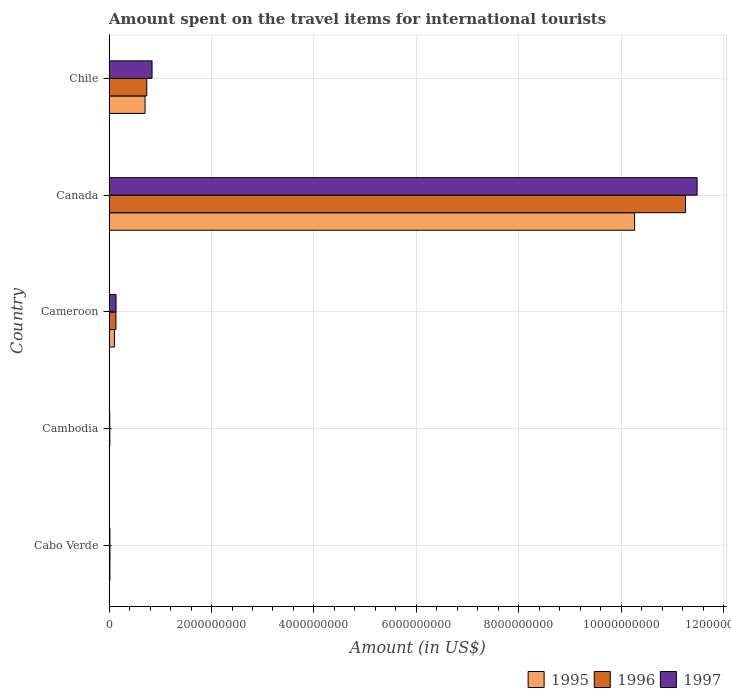How many different coloured bars are there?
Keep it short and to the point. 3. How many groups of bars are there?
Offer a terse response. 5. Are the number of bars on each tick of the Y-axis equal?
Offer a terse response. Yes. How many bars are there on the 5th tick from the bottom?
Your answer should be very brief. 3. What is the label of the 3rd group of bars from the top?
Your response must be concise. Cameroon. In how many cases, is the number of bars for a given country not equal to the number of legend labels?
Provide a short and direct response. 0. What is the amount spent on the travel items for international tourists in 1996 in Canada?
Provide a short and direct response. 1.13e+1. Across all countries, what is the maximum amount spent on the travel items for international tourists in 1995?
Your answer should be very brief. 1.03e+1. Across all countries, what is the minimum amount spent on the travel items for international tourists in 1997?
Give a very brief answer. 1.30e+07. In which country was the amount spent on the travel items for international tourists in 1997 minimum?
Your response must be concise. Cambodia. What is the total amount spent on the travel items for international tourists in 1997 in the graph?
Your answer should be very brief. 1.25e+1. What is the difference between the amount spent on the travel items for international tourists in 1995 in Cambodia and that in Canada?
Provide a succinct answer. -1.03e+1. What is the difference between the amount spent on the travel items for international tourists in 1996 in Chile and the amount spent on the travel items for international tourists in 1997 in Cambodia?
Give a very brief answer. 7.23e+08. What is the average amount spent on the travel items for international tourists in 1996 per country?
Offer a very short reply. 2.43e+09. What is the difference between the amount spent on the travel items for international tourists in 1995 and amount spent on the travel items for international tourists in 1997 in Chile?
Your response must be concise. -1.36e+08. What is the ratio of the amount spent on the travel items for international tourists in 1997 in Cabo Verde to that in Chile?
Provide a succinct answer. 0.02. What is the difference between the highest and the second highest amount spent on the travel items for international tourists in 1996?
Offer a very short reply. 1.05e+1. What is the difference between the highest and the lowest amount spent on the travel items for international tourists in 1996?
Your answer should be compact. 1.12e+1. In how many countries, is the amount spent on the travel items for international tourists in 1995 greater than the average amount spent on the travel items for international tourists in 1995 taken over all countries?
Give a very brief answer. 1. Is it the case that in every country, the sum of the amount spent on the travel items for international tourists in 1997 and amount spent on the travel items for international tourists in 1995 is greater than the amount spent on the travel items for international tourists in 1996?
Ensure brevity in your answer.  Yes. How many bars are there?
Ensure brevity in your answer.  15. How many countries are there in the graph?
Make the answer very short. 5. Are the values on the major ticks of X-axis written in scientific E-notation?
Provide a succinct answer. No. How are the legend labels stacked?
Provide a succinct answer. Horizontal. What is the title of the graph?
Offer a terse response. Amount spent on the travel items for international tourists. What is the label or title of the X-axis?
Your answer should be compact. Amount (in US$). What is the Amount (in US$) of 1995 in Cabo Verde?
Provide a short and direct response. 1.60e+07. What is the Amount (in US$) in 1996 in Cabo Verde?
Your answer should be very brief. 1.80e+07. What is the Amount (in US$) in 1997 in Cabo Verde?
Make the answer very short. 1.70e+07. What is the Amount (in US$) of 1995 in Cambodia?
Give a very brief answer. 8.00e+06. What is the Amount (in US$) of 1996 in Cambodia?
Your answer should be compact. 1.50e+07. What is the Amount (in US$) in 1997 in Cambodia?
Your answer should be compact. 1.30e+07. What is the Amount (in US$) of 1995 in Cameroon?
Your response must be concise. 1.05e+08. What is the Amount (in US$) of 1996 in Cameroon?
Keep it short and to the point. 1.34e+08. What is the Amount (in US$) of 1997 in Cameroon?
Your response must be concise. 1.36e+08. What is the Amount (in US$) of 1995 in Canada?
Your answer should be compact. 1.03e+1. What is the Amount (in US$) of 1996 in Canada?
Your answer should be very brief. 1.13e+1. What is the Amount (in US$) in 1997 in Canada?
Offer a very short reply. 1.15e+1. What is the Amount (in US$) of 1995 in Chile?
Provide a succinct answer. 7.03e+08. What is the Amount (in US$) of 1996 in Chile?
Your answer should be compact. 7.36e+08. What is the Amount (in US$) in 1997 in Chile?
Give a very brief answer. 8.39e+08. Across all countries, what is the maximum Amount (in US$) of 1995?
Provide a succinct answer. 1.03e+1. Across all countries, what is the maximum Amount (in US$) of 1996?
Offer a terse response. 1.13e+1. Across all countries, what is the maximum Amount (in US$) of 1997?
Ensure brevity in your answer.  1.15e+1. Across all countries, what is the minimum Amount (in US$) of 1995?
Make the answer very short. 8.00e+06. Across all countries, what is the minimum Amount (in US$) of 1996?
Offer a terse response. 1.50e+07. Across all countries, what is the minimum Amount (in US$) in 1997?
Make the answer very short. 1.30e+07. What is the total Amount (in US$) of 1995 in the graph?
Offer a terse response. 1.11e+1. What is the total Amount (in US$) of 1996 in the graph?
Give a very brief answer. 1.22e+1. What is the total Amount (in US$) of 1997 in the graph?
Offer a terse response. 1.25e+1. What is the difference between the Amount (in US$) in 1995 in Cabo Verde and that in Cameroon?
Your answer should be compact. -8.90e+07. What is the difference between the Amount (in US$) in 1996 in Cabo Verde and that in Cameroon?
Keep it short and to the point. -1.16e+08. What is the difference between the Amount (in US$) in 1997 in Cabo Verde and that in Cameroon?
Your answer should be very brief. -1.19e+08. What is the difference between the Amount (in US$) in 1995 in Cabo Verde and that in Canada?
Provide a succinct answer. -1.02e+1. What is the difference between the Amount (in US$) of 1996 in Cabo Verde and that in Canada?
Ensure brevity in your answer.  -1.12e+1. What is the difference between the Amount (in US$) of 1997 in Cabo Verde and that in Canada?
Offer a very short reply. -1.15e+1. What is the difference between the Amount (in US$) of 1995 in Cabo Verde and that in Chile?
Make the answer very short. -6.87e+08. What is the difference between the Amount (in US$) of 1996 in Cabo Verde and that in Chile?
Offer a terse response. -7.18e+08. What is the difference between the Amount (in US$) of 1997 in Cabo Verde and that in Chile?
Provide a short and direct response. -8.22e+08. What is the difference between the Amount (in US$) of 1995 in Cambodia and that in Cameroon?
Keep it short and to the point. -9.70e+07. What is the difference between the Amount (in US$) in 1996 in Cambodia and that in Cameroon?
Your answer should be compact. -1.19e+08. What is the difference between the Amount (in US$) of 1997 in Cambodia and that in Cameroon?
Offer a terse response. -1.23e+08. What is the difference between the Amount (in US$) in 1995 in Cambodia and that in Canada?
Your response must be concise. -1.03e+1. What is the difference between the Amount (in US$) in 1996 in Cambodia and that in Canada?
Offer a very short reply. -1.12e+1. What is the difference between the Amount (in US$) of 1997 in Cambodia and that in Canada?
Offer a terse response. -1.15e+1. What is the difference between the Amount (in US$) of 1995 in Cambodia and that in Chile?
Your answer should be compact. -6.95e+08. What is the difference between the Amount (in US$) in 1996 in Cambodia and that in Chile?
Your answer should be very brief. -7.21e+08. What is the difference between the Amount (in US$) of 1997 in Cambodia and that in Chile?
Keep it short and to the point. -8.26e+08. What is the difference between the Amount (in US$) of 1995 in Cameroon and that in Canada?
Give a very brief answer. -1.02e+1. What is the difference between the Amount (in US$) of 1996 in Cameroon and that in Canada?
Give a very brief answer. -1.11e+1. What is the difference between the Amount (in US$) of 1997 in Cameroon and that in Canada?
Offer a terse response. -1.13e+1. What is the difference between the Amount (in US$) in 1995 in Cameroon and that in Chile?
Give a very brief answer. -5.98e+08. What is the difference between the Amount (in US$) of 1996 in Cameroon and that in Chile?
Keep it short and to the point. -6.02e+08. What is the difference between the Amount (in US$) of 1997 in Cameroon and that in Chile?
Provide a succinct answer. -7.03e+08. What is the difference between the Amount (in US$) in 1995 in Canada and that in Chile?
Your answer should be compact. 9.56e+09. What is the difference between the Amount (in US$) in 1996 in Canada and that in Chile?
Give a very brief answer. 1.05e+1. What is the difference between the Amount (in US$) in 1997 in Canada and that in Chile?
Your response must be concise. 1.06e+1. What is the difference between the Amount (in US$) in 1996 in Cabo Verde and the Amount (in US$) in 1997 in Cambodia?
Provide a succinct answer. 5.00e+06. What is the difference between the Amount (in US$) in 1995 in Cabo Verde and the Amount (in US$) in 1996 in Cameroon?
Your answer should be compact. -1.18e+08. What is the difference between the Amount (in US$) of 1995 in Cabo Verde and the Amount (in US$) of 1997 in Cameroon?
Your answer should be very brief. -1.20e+08. What is the difference between the Amount (in US$) in 1996 in Cabo Verde and the Amount (in US$) in 1997 in Cameroon?
Your answer should be very brief. -1.18e+08. What is the difference between the Amount (in US$) of 1995 in Cabo Verde and the Amount (in US$) of 1996 in Canada?
Your answer should be very brief. -1.12e+1. What is the difference between the Amount (in US$) in 1995 in Cabo Verde and the Amount (in US$) in 1997 in Canada?
Ensure brevity in your answer.  -1.15e+1. What is the difference between the Amount (in US$) in 1996 in Cabo Verde and the Amount (in US$) in 1997 in Canada?
Give a very brief answer. -1.15e+1. What is the difference between the Amount (in US$) of 1995 in Cabo Verde and the Amount (in US$) of 1996 in Chile?
Your answer should be very brief. -7.20e+08. What is the difference between the Amount (in US$) in 1995 in Cabo Verde and the Amount (in US$) in 1997 in Chile?
Give a very brief answer. -8.23e+08. What is the difference between the Amount (in US$) in 1996 in Cabo Verde and the Amount (in US$) in 1997 in Chile?
Make the answer very short. -8.21e+08. What is the difference between the Amount (in US$) in 1995 in Cambodia and the Amount (in US$) in 1996 in Cameroon?
Provide a succinct answer. -1.26e+08. What is the difference between the Amount (in US$) of 1995 in Cambodia and the Amount (in US$) of 1997 in Cameroon?
Offer a terse response. -1.28e+08. What is the difference between the Amount (in US$) of 1996 in Cambodia and the Amount (in US$) of 1997 in Cameroon?
Your response must be concise. -1.21e+08. What is the difference between the Amount (in US$) of 1995 in Cambodia and the Amount (in US$) of 1996 in Canada?
Your answer should be very brief. -1.12e+1. What is the difference between the Amount (in US$) of 1995 in Cambodia and the Amount (in US$) of 1997 in Canada?
Provide a succinct answer. -1.15e+1. What is the difference between the Amount (in US$) in 1996 in Cambodia and the Amount (in US$) in 1997 in Canada?
Your answer should be very brief. -1.15e+1. What is the difference between the Amount (in US$) of 1995 in Cambodia and the Amount (in US$) of 1996 in Chile?
Your answer should be very brief. -7.28e+08. What is the difference between the Amount (in US$) of 1995 in Cambodia and the Amount (in US$) of 1997 in Chile?
Your response must be concise. -8.31e+08. What is the difference between the Amount (in US$) in 1996 in Cambodia and the Amount (in US$) in 1997 in Chile?
Ensure brevity in your answer.  -8.24e+08. What is the difference between the Amount (in US$) in 1995 in Cameroon and the Amount (in US$) in 1996 in Canada?
Provide a short and direct response. -1.11e+1. What is the difference between the Amount (in US$) of 1995 in Cameroon and the Amount (in US$) of 1997 in Canada?
Your answer should be very brief. -1.14e+1. What is the difference between the Amount (in US$) in 1996 in Cameroon and the Amount (in US$) in 1997 in Canada?
Your response must be concise. -1.13e+1. What is the difference between the Amount (in US$) in 1995 in Cameroon and the Amount (in US$) in 1996 in Chile?
Provide a short and direct response. -6.31e+08. What is the difference between the Amount (in US$) in 1995 in Cameroon and the Amount (in US$) in 1997 in Chile?
Provide a short and direct response. -7.34e+08. What is the difference between the Amount (in US$) in 1996 in Cameroon and the Amount (in US$) in 1997 in Chile?
Ensure brevity in your answer.  -7.05e+08. What is the difference between the Amount (in US$) in 1995 in Canada and the Amount (in US$) in 1996 in Chile?
Give a very brief answer. 9.52e+09. What is the difference between the Amount (in US$) in 1995 in Canada and the Amount (in US$) in 1997 in Chile?
Make the answer very short. 9.42e+09. What is the difference between the Amount (in US$) of 1996 in Canada and the Amount (in US$) of 1997 in Chile?
Ensure brevity in your answer.  1.04e+1. What is the average Amount (in US$) of 1995 per country?
Your answer should be very brief. 2.22e+09. What is the average Amount (in US$) of 1996 per country?
Ensure brevity in your answer.  2.43e+09. What is the average Amount (in US$) in 1997 per country?
Ensure brevity in your answer.  2.50e+09. What is the difference between the Amount (in US$) of 1995 and Amount (in US$) of 1997 in Cabo Verde?
Keep it short and to the point. -1.00e+06. What is the difference between the Amount (in US$) of 1996 and Amount (in US$) of 1997 in Cabo Verde?
Offer a terse response. 1.00e+06. What is the difference between the Amount (in US$) in 1995 and Amount (in US$) in 1996 in Cambodia?
Provide a succinct answer. -7.00e+06. What is the difference between the Amount (in US$) of 1995 and Amount (in US$) of 1997 in Cambodia?
Provide a short and direct response. -5.00e+06. What is the difference between the Amount (in US$) in 1995 and Amount (in US$) in 1996 in Cameroon?
Your answer should be compact. -2.90e+07. What is the difference between the Amount (in US$) of 1995 and Amount (in US$) of 1997 in Cameroon?
Provide a short and direct response. -3.10e+07. What is the difference between the Amount (in US$) in 1995 and Amount (in US$) in 1996 in Canada?
Offer a terse response. -9.94e+08. What is the difference between the Amount (in US$) in 1995 and Amount (in US$) in 1997 in Canada?
Give a very brief answer. -1.22e+09. What is the difference between the Amount (in US$) of 1996 and Amount (in US$) of 1997 in Canada?
Make the answer very short. -2.26e+08. What is the difference between the Amount (in US$) of 1995 and Amount (in US$) of 1996 in Chile?
Keep it short and to the point. -3.30e+07. What is the difference between the Amount (in US$) of 1995 and Amount (in US$) of 1997 in Chile?
Offer a very short reply. -1.36e+08. What is the difference between the Amount (in US$) of 1996 and Amount (in US$) of 1997 in Chile?
Offer a very short reply. -1.03e+08. What is the ratio of the Amount (in US$) in 1995 in Cabo Verde to that in Cambodia?
Make the answer very short. 2. What is the ratio of the Amount (in US$) in 1996 in Cabo Verde to that in Cambodia?
Provide a succinct answer. 1.2. What is the ratio of the Amount (in US$) in 1997 in Cabo Verde to that in Cambodia?
Your response must be concise. 1.31. What is the ratio of the Amount (in US$) in 1995 in Cabo Verde to that in Cameroon?
Your answer should be compact. 0.15. What is the ratio of the Amount (in US$) in 1996 in Cabo Verde to that in Cameroon?
Your response must be concise. 0.13. What is the ratio of the Amount (in US$) of 1995 in Cabo Verde to that in Canada?
Keep it short and to the point. 0. What is the ratio of the Amount (in US$) of 1996 in Cabo Verde to that in Canada?
Provide a short and direct response. 0. What is the ratio of the Amount (in US$) in 1997 in Cabo Verde to that in Canada?
Offer a very short reply. 0. What is the ratio of the Amount (in US$) of 1995 in Cabo Verde to that in Chile?
Keep it short and to the point. 0.02. What is the ratio of the Amount (in US$) of 1996 in Cabo Verde to that in Chile?
Ensure brevity in your answer.  0.02. What is the ratio of the Amount (in US$) in 1997 in Cabo Verde to that in Chile?
Offer a very short reply. 0.02. What is the ratio of the Amount (in US$) in 1995 in Cambodia to that in Cameroon?
Provide a succinct answer. 0.08. What is the ratio of the Amount (in US$) in 1996 in Cambodia to that in Cameroon?
Make the answer very short. 0.11. What is the ratio of the Amount (in US$) in 1997 in Cambodia to that in Cameroon?
Your answer should be compact. 0.1. What is the ratio of the Amount (in US$) of 1995 in Cambodia to that in Canada?
Provide a short and direct response. 0. What is the ratio of the Amount (in US$) in 1996 in Cambodia to that in Canada?
Make the answer very short. 0. What is the ratio of the Amount (in US$) of 1997 in Cambodia to that in Canada?
Offer a terse response. 0. What is the ratio of the Amount (in US$) of 1995 in Cambodia to that in Chile?
Offer a terse response. 0.01. What is the ratio of the Amount (in US$) of 1996 in Cambodia to that in Chile?
Your answer should be compact. 0.02. What is the ratio of the Amount (in US$) of 1997 in Cambodia to that in Chile?
Offer a very short reply. 0.02. What is the ratio of the Amount (in US$) of 1995 in Cameroon to that in Canada?
Your answer should be very brief. 0.01. What is the ratio of the Amount (in US$) of 1996 in Cameroon to that in Canada?
Offer a very short reply. 0.01. What is the ratio of the Amount (in US$) in 1997 in Cameroon to that in Canada?
Ensure brevity in your answer.  0.01. What is the ratio of the Amount (in US$) in 1995 in Cameroon to that in Chile?
Give a very brief answer. 0.15. What is the ratio of the Amount (in US$) in 1996 in Cameroon to that in Chile?
Give a very brief answer. 0.18. What is the ratio of the Amount (in US$) of 1997 in Cameroon to that in Chile?
Give a very brief answer. 0.16. What is the ratio of the Amount (in US$) of 1995 in Canada to that in Chile?
Offer a terse response. 14.59. What is the ratio of the Amount (in US$) of 1996 in Canada to that in Chile?
Your response must be concise. 15.29. What is the ratio of the Amount (in US$) in 1997 in Canada to that in Chile?
Offer a terse response. 13.68. What is the difference between the highest and the second highest Amount (in US$) of 1995?
Offer a terse response. 9.56e+09. What is the difference between the highest and the second highest Amount (in US$) in 1996?
Offer a very short reply. 1.05e+1. What is the difference between the highest and the second highest Amount (in US$) in 1997?
Offer a terse response. 1.06e+1. What is the difference between the highest and the lowest Amount (in US$) of 1995?
Your answer should be compact. 1.03e+1. What is the difference between the highest and the lowest Amount (in US$) in 1996?
Make the answer very short. 1.12e+1. What is the difference between the highest and the lowest Amount (in US$) of 1997?
Your answer should be very brief. 1.15e+1. 